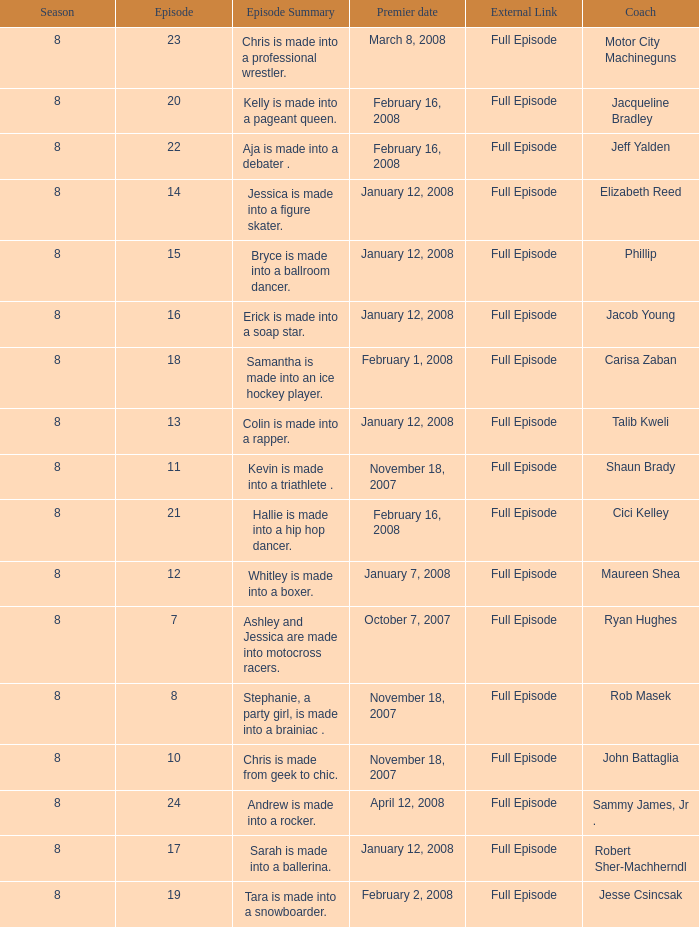How many seasons feature Rob Masek? 1.0. 